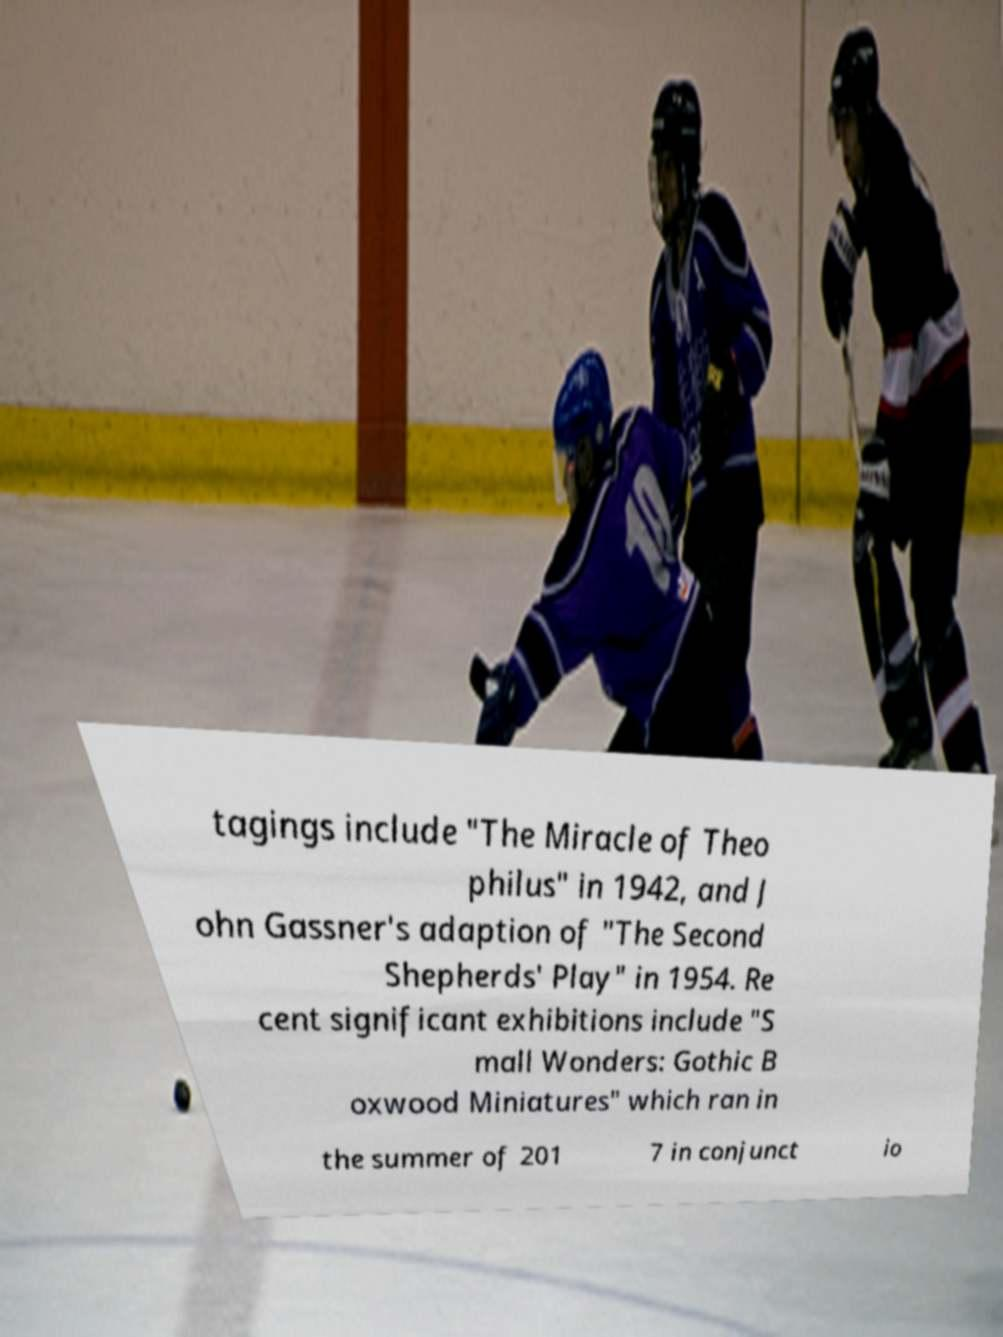There's text embedded in this image that I need extracted. Can you transcribe it verbatim? tagings include "The Miracle of Theo philus" in 1942, and J ohn Gassner's adaption of "The Second Shepherds' Play" in 1954. Re cent significant exhibitions include "S mall Wonders: Gothic B oxwood Miniatures" which ran in the summer of 201 7 in conjunct io 